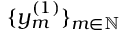<formula> <loc_0><loc_0><loc_500><loc_500>\{ y _ { m } ^ { ( 1 ) } \} _ { m \in \mathbb { N } }</formula> 